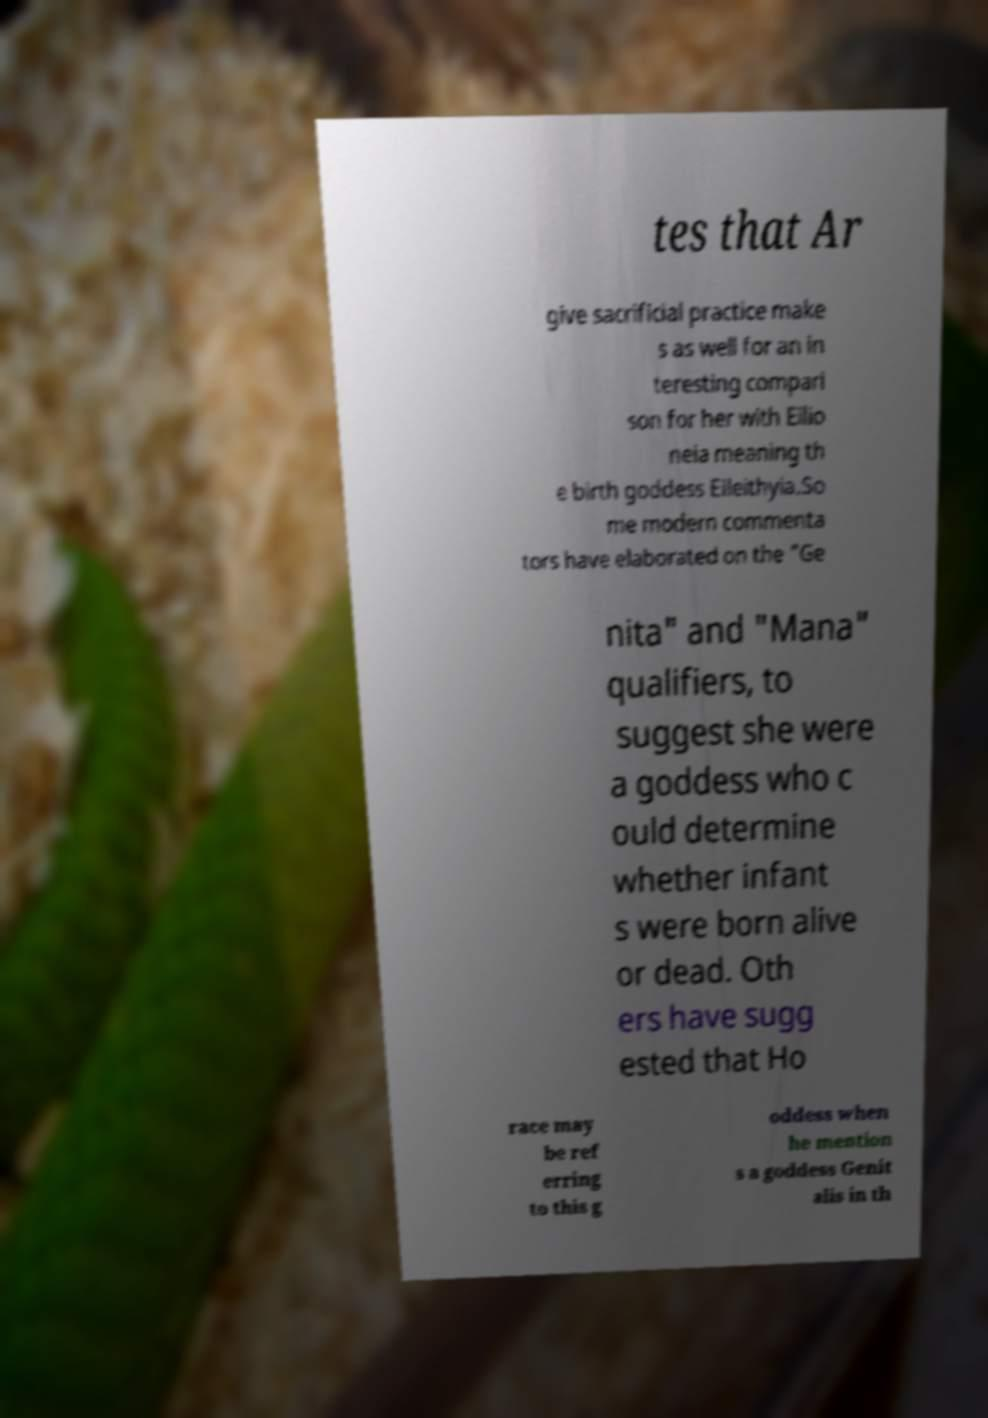There's text embedded in this image that I need extracted. Can you transcribe it verbatim? tes that Ar give sacrificial practice make s as well for an in teresting compari son for her with Eilio neia meaning th e birth goddess Eileithyia.So me modern commenta tors have elaborated on the "Ge nita" and "Mana" qualifiers, to suggest she were a goddess who c ould determine whether infant s were born alive or dead. Oth ers have sugg ested that Ho race may be ref erring to this g oddess when he mention s a goddess Genit alis in th 